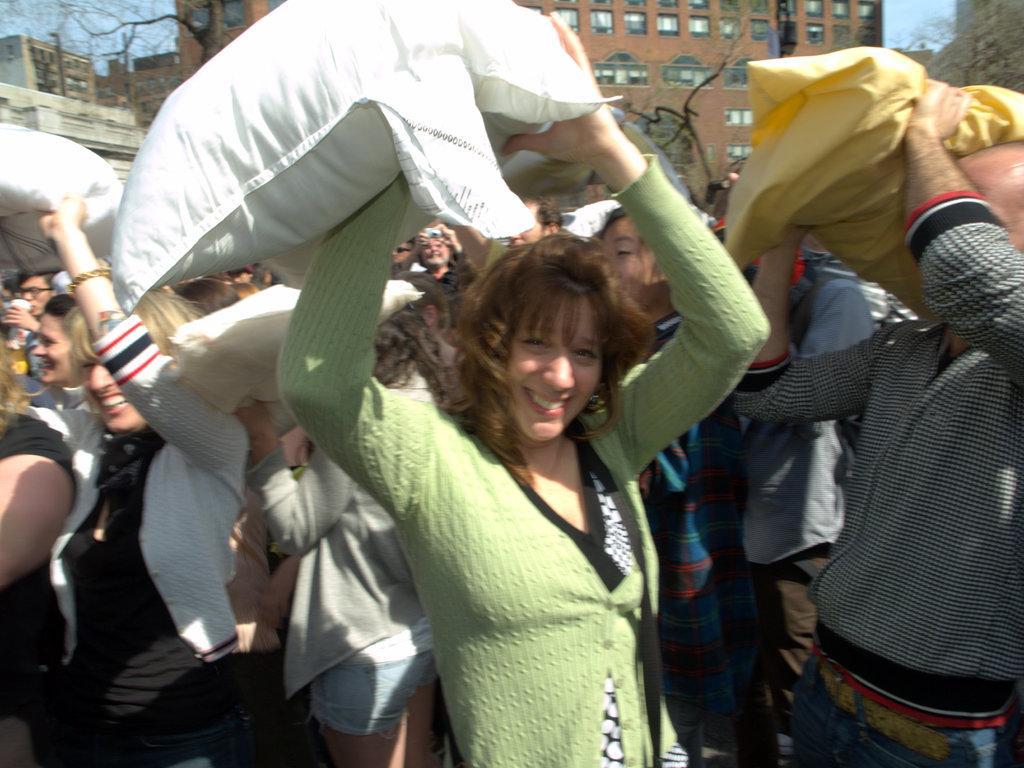Could you give a brief overview of what you see in this image? In this picture there are few persons holding an object in their hands and there are few buildings and dried trees which has no leaves on it is in the background. 